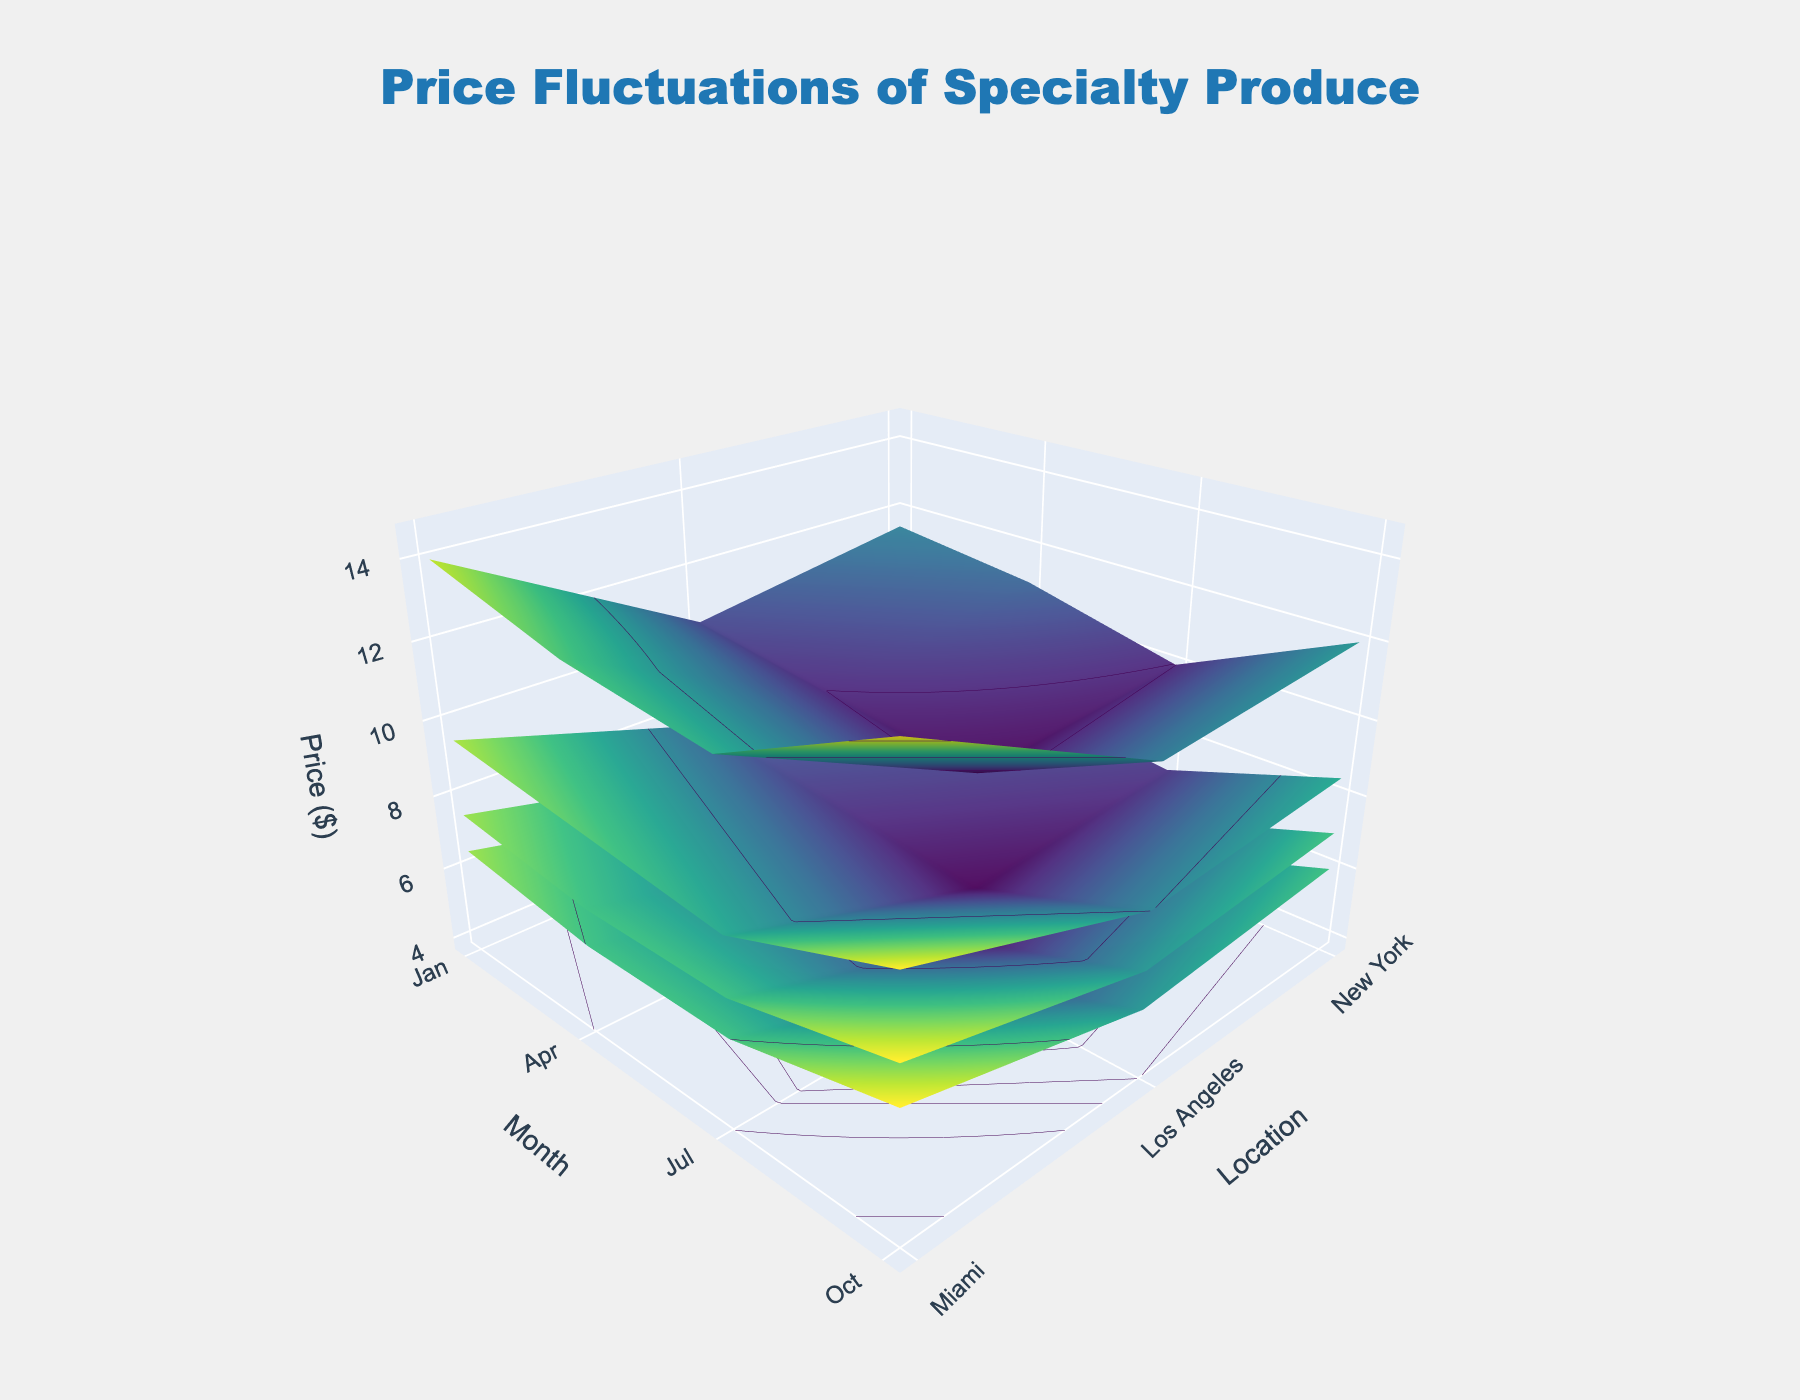What's the title of the figure? The title of the plot is located at the top center and summarizes the main subject of the figure.
Answer: Price Fluctuations of Specialty Produce What is the price of Dragonfruit in New York in October? Look at the x-axis for "New York," then the y-axis for "October," and find the height (z-value) of the surface for Dragonfruit.
Answer: 9.99 During which month and in which location was the price of Passion Fruit at its lowest? A price comparison across all months and locations reveals the lowest point on the Passion Fruit surface. The lowest price can be identified uniquely.
Answer: July, Miami What's the average price of Lychee in Miami over the year? Sum the Lychee prices for Miami from January, April, July, and October, then divide by the number of months (4). (9.99 + 10.49 + 9.49 + 11.49)/4
Answer: 10.365 Which fruit showed the most price fluctuation in New York throughout the year? Observe the ranges of the z-values for each fruit's surface in New York. The fruit with the greatest range has the most fluctuation.
Answer: Lychee How does the price of Starfruit in Los Angeles compare between January and October? Compare the z-values for Starfruit in Los Angeles between the y-axis positions of January and October.
Answer: 5.99 in January and 6.99 in October Which location generally has the lowest prices for Passion Fruit? Compare the z-values for Passion Fruit across all locations; the location with consistently lower values has the lowest prices.
Answer: Miami Is there a seasonal trend observed for Dragonfruit prices? Analyze the z-value pattern for Dragonfruit across all months in each location. If there's a recurring pattern through the months, it indicates a seasonal trend.
Answer: Yes, higher in April and October Comparing Los Angeles and New York, which location has higher prices for Starfruit in July? Compare the surface heights (z-values) of Starfruit for Los Angeles and New York locations in July.
Answer: New York 